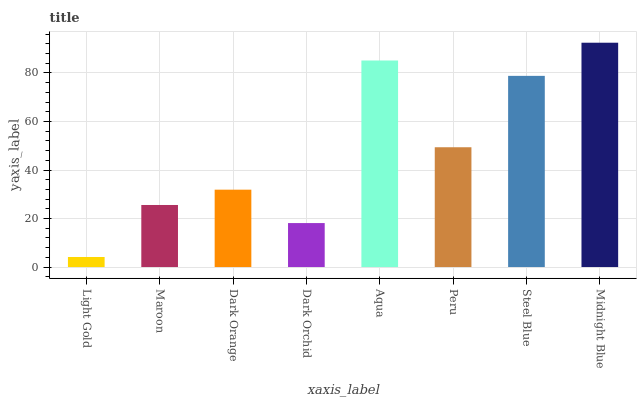Is Light Gold the minimum?
Answer yes or no. Yes. Is Midnight Blue the maximum?
Answer yes or no. Yes. Is Maroon the minimum?
Answer yes or no. No. Is Maroon the maximum?
Answer yes or no. No. Is Maroon greater than Light Gold?
Answer yes or no. Yes. Is Light Gold less than Maroon?
Answer yes or no. Yes. Is Light Gold greater than Maroon?
Answer yes or no. No. Is Maroon less than Light Gold?
Answer yes or no. No. Is Peru the high median?
Answer yes or no. Yes. Is Dark Orange the low median?
Answer yes or no. Yes. Is Light Gold the high median?
Answer yes or no. No. Is Maroon the low median?
Answer yes or no. No. 